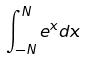<formula> <loc_0><loc_0><loc_500><loc_500>\int _ { - N } ^ { N } e ^ { x } d x</formula> 